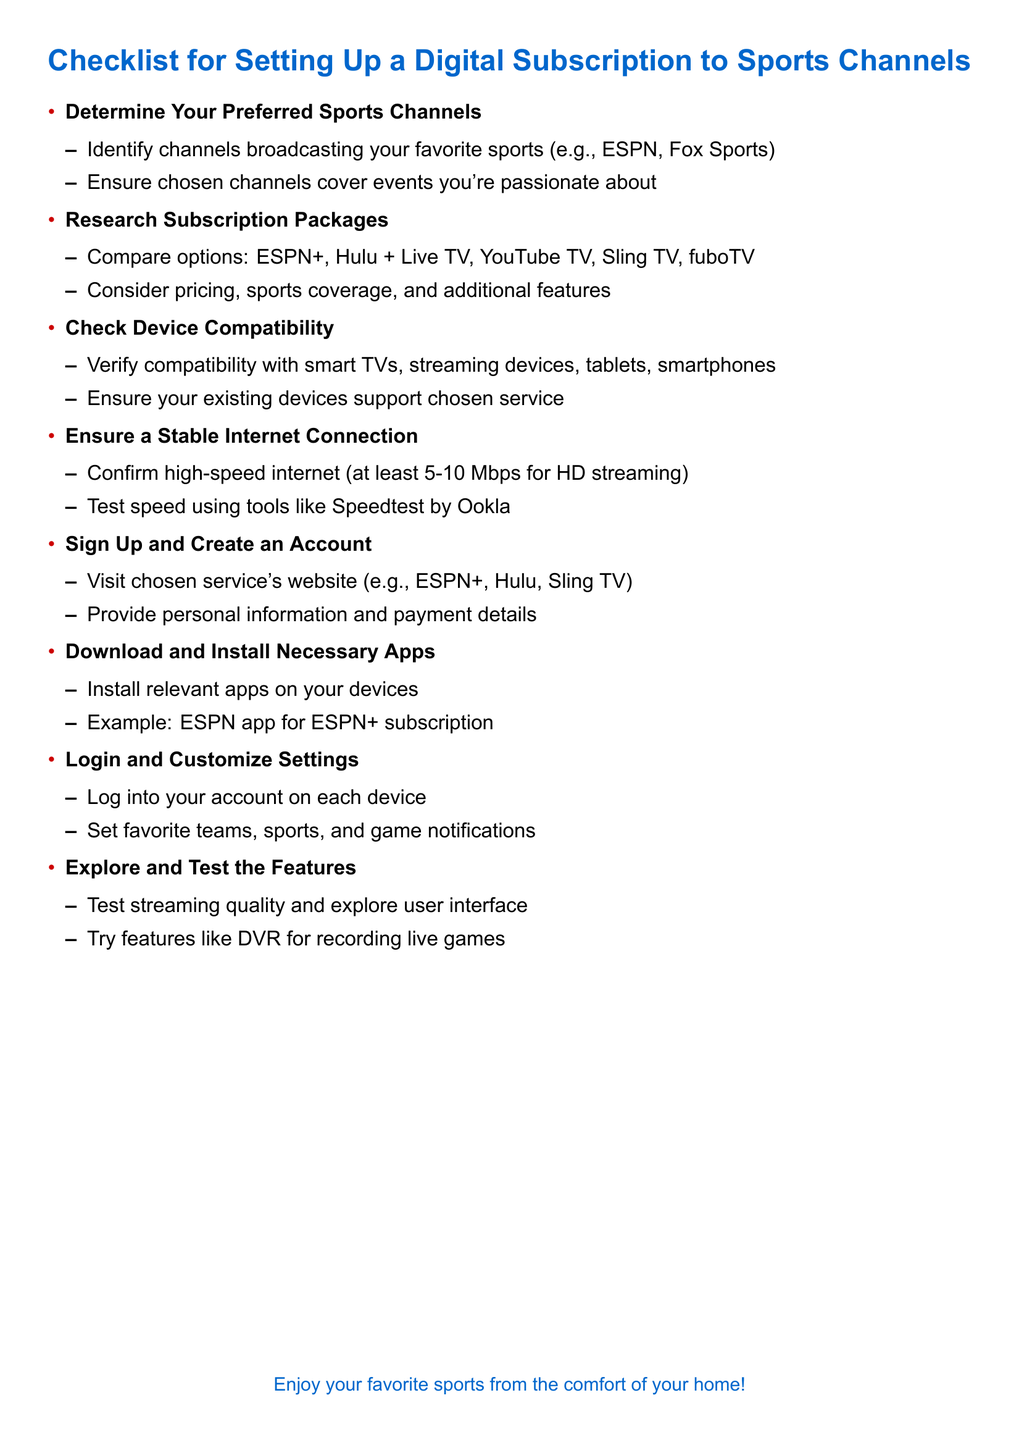what are some recommended sports channels? The document lists specific channels such as ESPN and Fox Sports as examples.
Answer: ESPN, Fox Sports what is the minimum internet speed suggested for HD streaming? The document states that at least 5-10 Mbps is required for HD streaming.
Answer: 5-10 Mbps which streaming services are mentioned in the research section? The document lists ESPN+, Hulu + Live TV, YouTube TV, Sling TV, and fuboTV as options to compare.
Answer: ESPN+, Hulu + Live TV, YouTube TV, Sling TV, fuboTV what step follows signing up and creating an account? The next step after signing up is to download and install the necessary apps on your devices.
Answer: Download and Install Necessary Apps how can you customize your viewing experience? The document suggests logging in and setting favorite teams, sports, and notifications for games.
Answer: Favorite teams, sports, game notifications what must be ensured for device compatibility? The document emphasizes verifying that your devices support the chosen streaming service.
Answer: Device support what is the final step suggested in the checklist? The checklist concludes with exploring and testing the features of the streaming service.
Answer: Explore and Test the Features what should you do to verify a stable internet connection? The document recommends confirming high-speed internet and testing speed using tools like Speedtest.
Answer: Test speed using Speedtest 